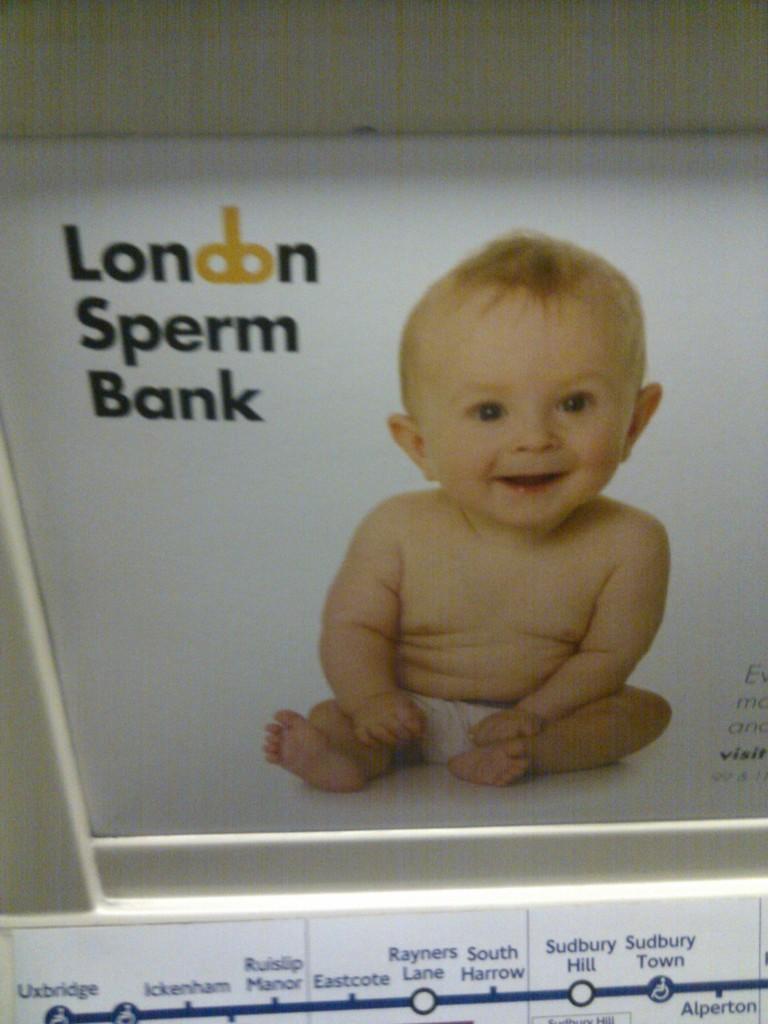How would you summarize this image in a sentence or two? In this image, we can see a poster, on that poster we can see a picture of a baby and some text. 